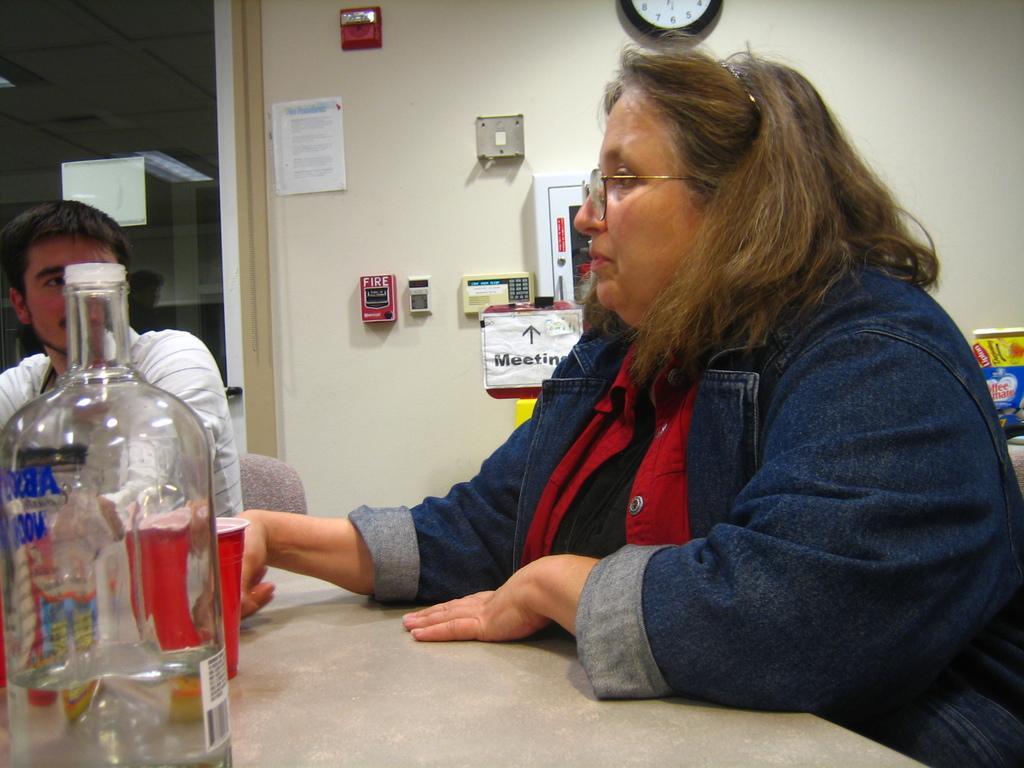In one or two sentences, can you explain what this image depicts? This woman wore jacket and sitting on a chair. In-front of this woman there is a table, on this table there is a bottle and cup. This man is also sitting on a chair. On wall there is a clock, paper and box. On top there is a light. 